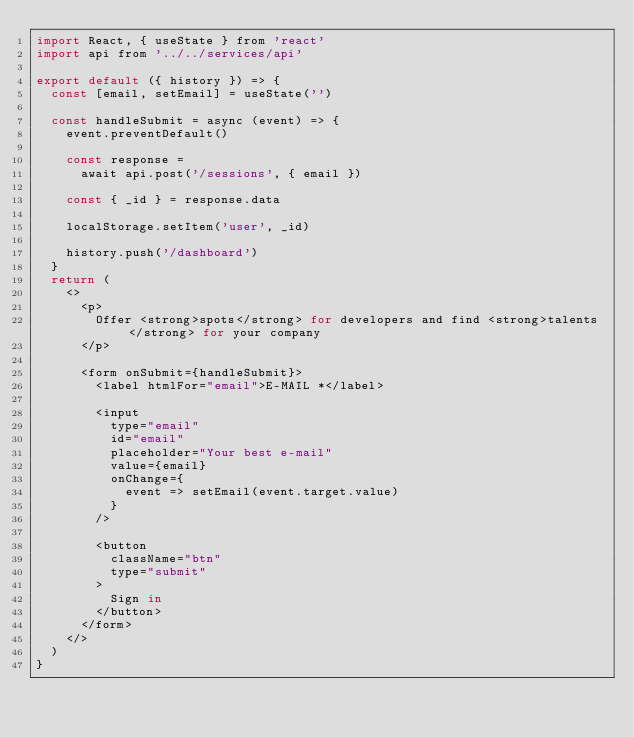Convert code to text. <code><loc_0><loc_0><loc_500><loc_500><_JavaScript_>import React, { useState } from 'react'
import api from '../../services/api'

export default ({ history }) => {
  const [email, setEmail] = useState('')

  const handleSubmit = async (event) => {
    event.preventDefault()

    const response =
      await api.post('/sessions', { email })

    const { _id } = response.data

    localStorage.setItem('user', _id)

    history.push('/dashboard')
  }
  return (
    <>
      <p>
        Offer <strong>spots</strong> for developers and find <strong>talents</strong> for your company
      </p>

      <form onSubmit={handleSubmit}>
        <label htmlFor="email">E-MAIL *</label>

        <input
          type="email"
          id="email"
          placeholder="Your best e-mail"
          value={email}
          onChange={
            event => setEmail(event.target.value)
          }
        />

        <button
          className="btn"
          type="submit"
        >
          Sign in
        </button>
      </form>
    </>
  )
}
</code> 